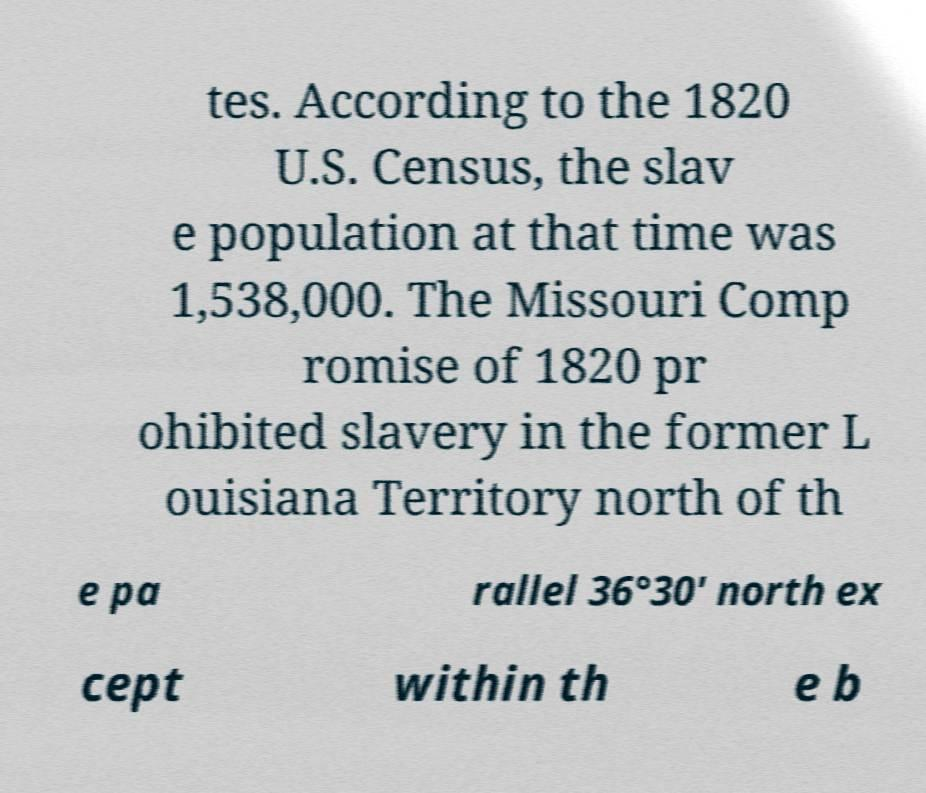There's text embedded in this image that I need extracted. Can you transcribe it verbatim? tes. According to the 1820 U.S. Census, the slav e population at that time was 1,538,000. The Missouri Comp romise of 1820 pr ohibited slavery in the former L ouisiana Territory north of th e pa rallel 36°30′ north ex cept within th e b 